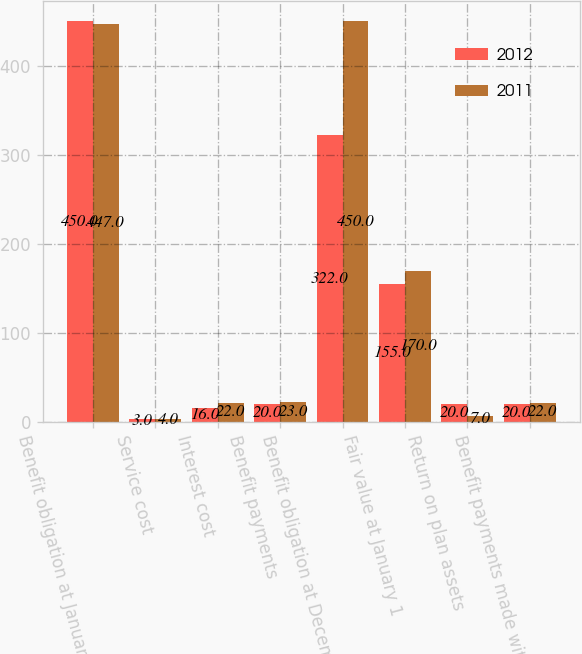Convert chart. <chart><loc_0><loc_0><loc_500><loc_500><stacked_bar_chart><ecel><fcel>Benefit obligation at January<fcel>Service cost<fcel>Interest cost<fcel>Benefit payments<fcel>Benefit obligation at December<fcel>Fair value at January 1<fcel>Return on plan assets<fcel>Benefit payments made with<nl><fcel>2012<fcel>450<fcel>3<fcel>16<fcel>20<fcel>322<fcel>155<fcel>20<fcel>20<nl><fcel>2011<fcel>447<fcel>4<fcel>22<fcel>23<fcel>450<fcel>170<fcel>7<fcel>22<nl></chart> 